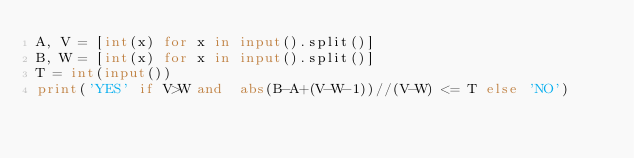Convert code to text. <code><loc_0><loc_0><loc_500><loc_500><_Python_>A, V = [int(x) for x in input().split()]
B, W = [int(x) for x in input().split()]
T = int(input())    
print('YES' if V>W and  abs(B-A+(V-W-1))//(V-W) <= T else 'NO')
</code> 